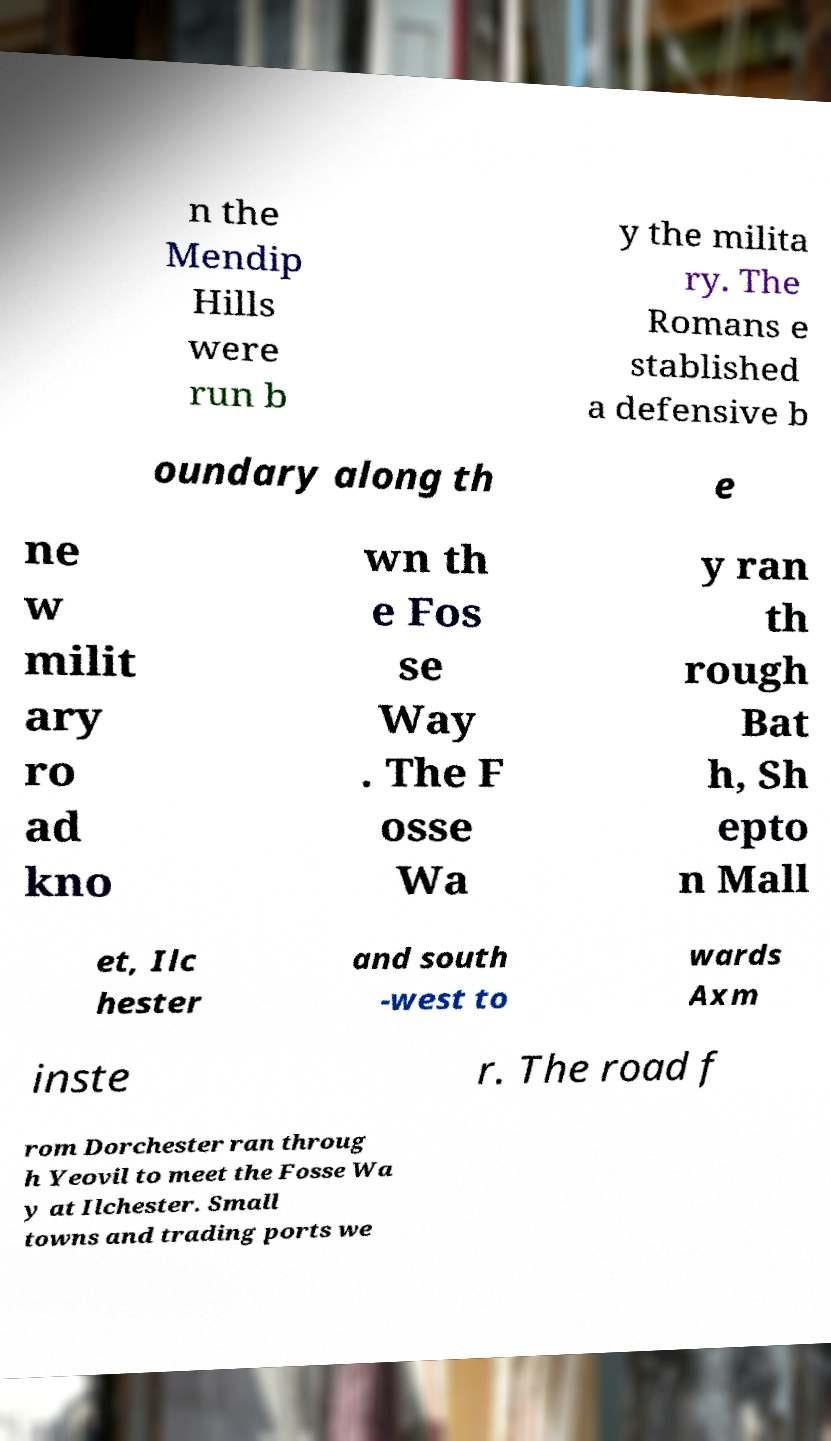There's text embedded in this image that I need extracted. Can you transcribe it verbatim? n the Mendip Hills were run b y the milita ry. The Romans e stablished a defensive b oundary along th e ne w milit ary ro ad kno wn th e Fos se Way . The F osse Wa y ran th rough Bat h, Sh epto n Mall et, Ilc hester and south -west to wards Axm inste r. The road f rom Dorchester ran throug h Yeovil to meet the Fosse Wa y at Ilchester. Small towns and trading ports we 